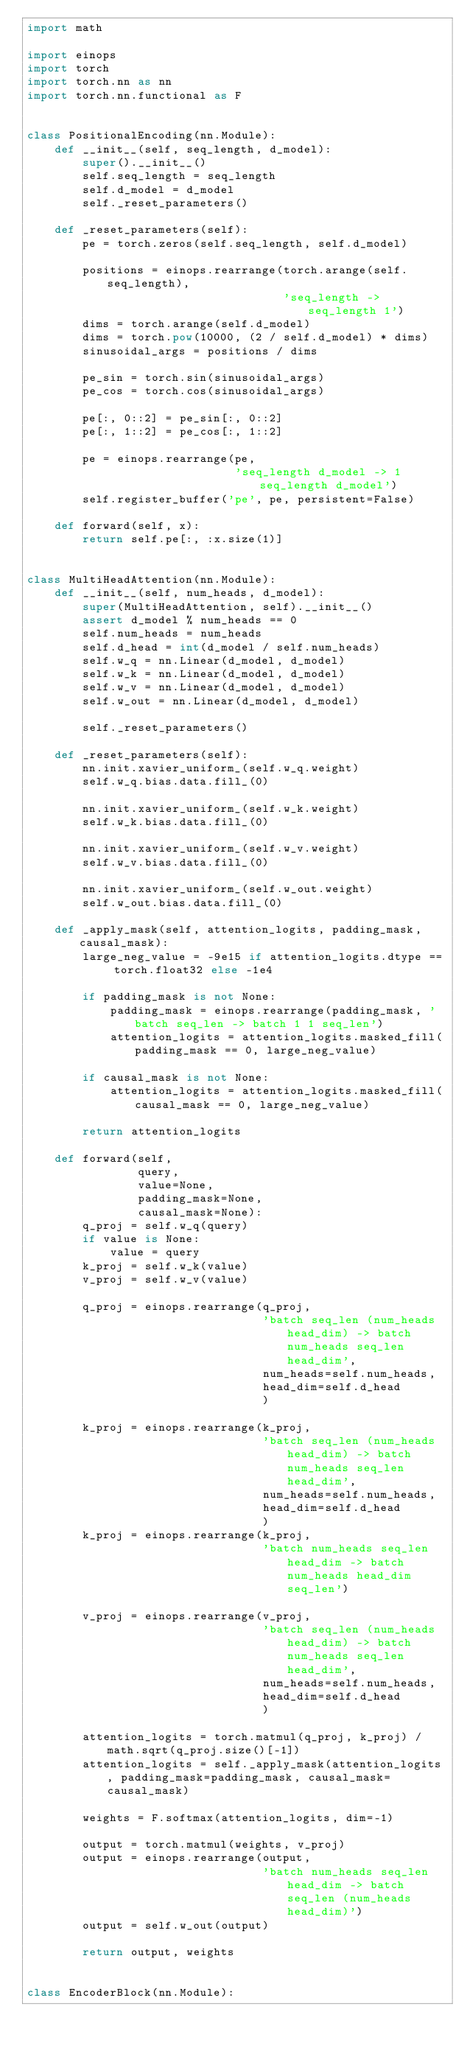Convert code to text. <code><loc_0><loc_0><loc_500><loc_500><_Python_>import math

import einops
import torch
import torch.nn as nn
import torch.nn.functional as F


class PositionalEncoding(nn.Module):
    def __init__(self, seq_length, d_model):
        super().__init__()
        self.seq_length = seq_length
        self.d_model = d_model
        self._reset_parameters()

    def _reset_parameters(self):
        pe = torch.zeros(self.seq_length, self.d_model)

        positions = einops.rearrange(torch.arange(self.seq_length),
                                     'seq_length -> seq_length 1')
        dims = torch.arange(self.d_model)
        dims = torch.pow(10000, (2 / self.d_model) * dims)
        sinusoidal_args = positions / dims

        pe_sin = torch.sin(sinusoidal_args)
        pe_cos = torch.cos(sinusoidal_args)

        pe[:, 0::2] = pe_sin[:, 0::2]
        pe[:, 1::2] = pe_cos[:, 1::2]

        pe = einops.rearrange(pe,
                              'seq_length d_model -> 1 seq_length d_model')
        self.register_buffer('pe', pe, persistent=False)

    def forward(self, x):
        return self.pe[:, :x.size(1)]


class MultiHeadAttention(nn.Module):
    def __init__(self, num_heads, d_model):
        super(MultiHeadAttention, self).__init__()
        assert d_model % num_heads == 0
        self.num_heads = num_heads
        self.d_head = int(d_model / self.num_heads)
        self.w_q = nn.Linear(d_model, d_model)
        self.w_k = nn.Linear(d_model, d_model)
        self.w_v = nn.Linear(d_model, d_model)
        self.w_out = nn.Linear(d_model, d_model)

        self._reset_parameters()

    def _reset_parameters(self):
        nn.init.xavier_uniform_(self.w_q.weight)
        self.w_q.bias.data.fill_(0)

        nn.init.xavier_uniform_(self.w_k.weight)
        self.w_k.bias.data.fill_(0)

        nn.init.xavier_uniform_(self.w_v.weight)
        self.w_v.bias.data.fill_(0)

        nn.init.xavier_uniform_(self.w_out.weight)
        self.w_out.bias.data.fill_(0)

    def _apply_mask(self, attention_logits, padding_mask, causal_mask):
        large_neg_value = -9e15 if attention_logits.dtype == torch.float32 else -1e4

        if padding_mask is not None:
            padding_mask = einops.rearrange(padding_mask, 'batch seq_len -> batch 1 1 seq_len')
            attention_logits = attention_logits.masked_fill(padding_mask == 0, large_neg_value)

        if causal_mask is not None:
            attention_logits = attention_logits.masked_fill(causal_mask == 0, large_neg_value)

        return attention_logits

    def forward(self,
                query,
                value=None,
                padding_mask=None,
                causal_mask=None):
        q_proj = self.w_q(query)
        if value is None:
            value = query
        k_proj = self.w_k(value)
        v_proj = self.w_v(value)

        q_proj = einops.rearrange(q_proj,
                                  'batch seq_len (num_heads head_dim) -> batch num_heads seq_len head_dim',
                                  num_heads=self.num_heads,
                                  head_dim=self.d_head
                                  )

        k_proj = einops.rearrange(k_proj,
                                  'batch seq_len (num_heads head_dim) -> batch num_heads seq_len head_dim',
                                  num_heads=self.num_heads,
                                  head_dim=self.d_head
                                  )
        k_proj = einops.rearrange(k_proj,
                                  'batch num_heads seq_len head_dim -> batch num_heads head_dim seq_len')

        v_proj = einops.rearrange(v_proj,
                                  'batch seq_len (num_heads head_dim) -> batch num_heads seq_len head_dim',
                                  num_heads=self.num_heads,
                                  head_dim=self.d_head
                                  )

        attention_logits = torch.matmul(q_proj, k_proj) / math.sqrt(q_proj.size()[-1])
        attention_logits = self._apply_mask(attention_logits, padding_mask=padding_mask, causal_mask=causal_mask)

        weights = F.softmax(attention_logits, dim=-1)

        output = torch.matmul(weights, v_proj)
        output = einops.rearrange(output,
                                  'batch num_heads seq_len head_dim -> batch seq_len (num_heads head_dim)')
        output = self.w_out(output)

        return output, weights


class EncoderBlock(nn.Module):</code> 